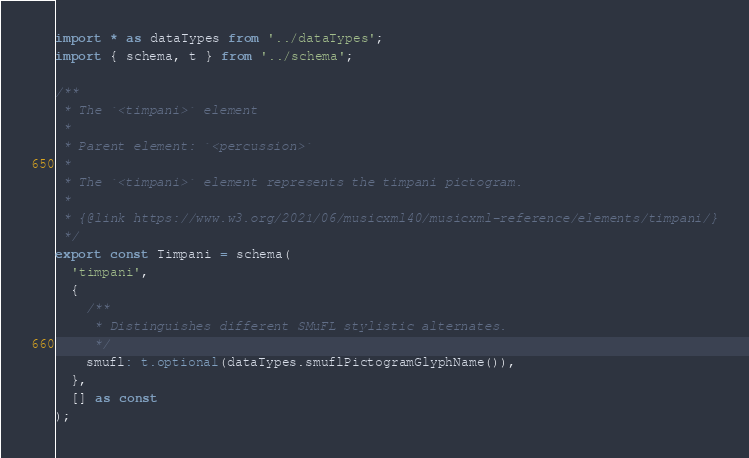<code> <loc_0><loc_0><loc_500><loc_500><_TypeScript_>import * as dataTypes from '../dataTypes';
import { schema, t } from '../schema';

/**
 * The `<timpani>` element
 *
 * Parent element: `<percussion>`
 *
 * The `<timpani>` element represents the timpani pictogram.
 *
 * {@link https://www.w3.org/2021/06/musicxml40/musicxml-reference/elements/timpani/}
 */
export const Timpani = schema(
  'timpani',
  {
    /**
     * Distinguishes different SMuFL stylistic alternates.
     */
    smufl: t.optional(dataTypes.smuflPictogramGlyphName()),
  },
  [] as const
);
</code> 